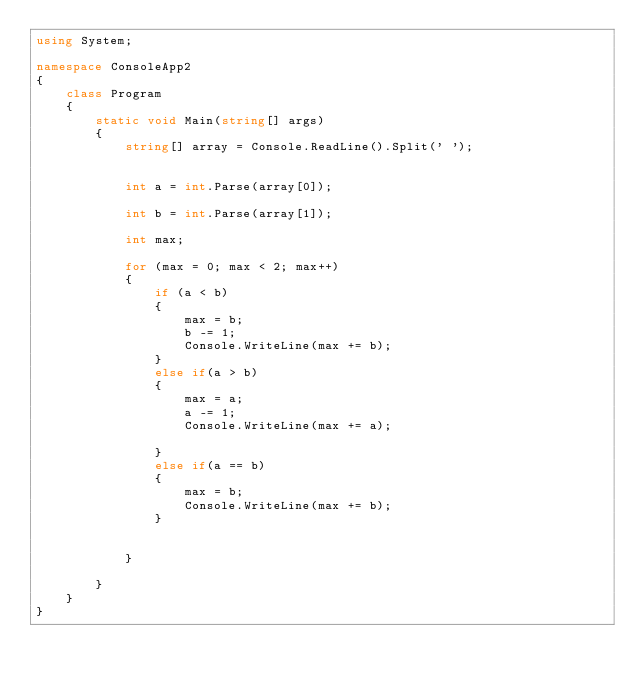<code> <loc_0><loc_0><loc_500><loc_500><_C#_>using System;

namespace ConsoleApp2
{
    class Program
    {
        static void Main(string[] args)
        {
            string[] array = Console.ReadLine().Split(' ');


            int a = int.Parse(array[0]);

            int b = int.Parse(array[1]);

            int max;

            for (max = 0; max < 2; max++)
            {
                if (a < b)
                {
                    max = b;
                    b -= 1;
                    Console.WriteLine(max += b);
                }
                else if(a > b)
                {
                    max = a;
                    a -= 1;
                    Console.WriteLine(max += a);

                }
                else if(a == b)
                {
                    max = b;
                    Console.WriteLine(max += b);
                }
                
                
            }
                  
        }
    }
}
</code> 